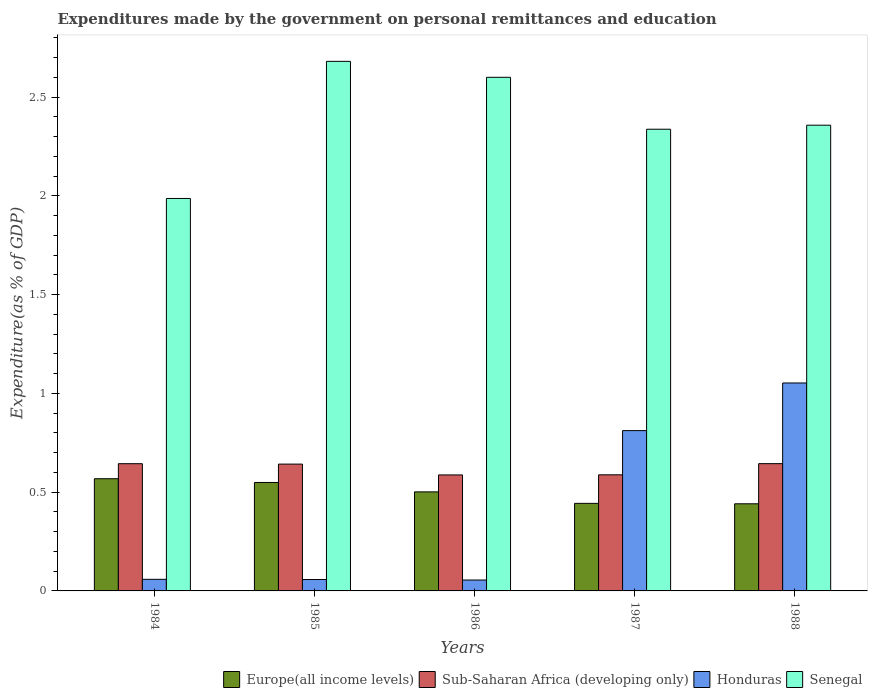How many different coloured bars are there?
Your answer should be very brief. 4. How many groups of bars are there?
Keep it short and to the point. 5. Are the number of bars on each tick of the X-axis equal?
Offer a very short reply. Yes. How many bars are there on the 4th tick from the left?
Provide a succinct answer. 4. What is the label of the 3rd group of bars from the left?
Offer a terse response. 1986. What is the expenditures made by the government on personal remittances and education in Europe(all income levels) in 1988?
Make the answer very short. 0.44. Across all years, what is the maximum expenditures made by the government on personal remittances and education in Europe(all income levels)?
Your answer should be compact. 0.57. Across all years, what is the minimum expenditures made by the government on personal remittances and education in Senegal?
Make the answer very short. 1.99. In which year was the expenditures made by the government on personal remittances and education in Senegal minimum?
Your response must be concise. 1984. What is the total expenditures made by the government on personal remittances and education in Honduras in the graph?
Provide a short and direct response. 2.04. What is the difference between the expenditures made by the government on personal remittances and education in Honduras in 1987 and that in 1988?
Provide a succinct answer. -0.24. What is the difference between the expenditures made by the government on personal remittances and education in Europe(all income levels) in 1986 and the expenditures made by the government on personal remittances and education in Honduras in 1985?
Give a very brief answer. 0.44. What is the average expenditures made by the government on personal remittances and education in Honduras per year?
Provide a short and direct response. 0.41. In the year 1985, what is the difference between the expenditures made by the government on personal remittances and education in Europe(all income levels) and expenditures made by the government on personal remittances and education in Sub-Saharan Africa (developing only)?
Provide a succinct answer. -0.09. What is the ratio of the expenditures made by the government on personal remittances and education in Senegal in 1984 to that in 1987?
Your answer should be very brief. 0.85. Is the expenditures made by the government on personal remittances and education in Honduras in 1985 less than that in 1987?
Your response must be concise. Yes. Is the difference between the expenditures made by the government on personal remittances and education in Europe(all income levels) in 1984 and 1985 greater than the difference between the expenditures made by the government on personal remittances and education in Sub-Saharan Africa (developing only) in 1984 and 1985?
Offer a very short reply. Yes. What is the difference between the highest and the second highest expenditures made by the government on personal remittances and education in Sub-Saharan Africa (developing only)?
Provide a succinct answer. 0. What is the difference between the highest and the lowest expenditures made by the government on personal remittances and education in Sub-Saharan Africa (developing only)?
Provide a short and direct response. 0.06. In how many years, is the expenditures made by the government on personal remittances and education in Europe(all income levels) greater than the average expenditures made by the government on personal remittances and education in Europe(all income levels) taken over all years?
Provide a succinct answer. 3. Is the sum of the expenditures made by the government on personal remittances and education in Sub-Saharan Africa (developing only) in 1986 and 1987 greater than the maximum expenditures made by the government on personal remittances and education in Europe(all income levels) across all years?
Keep it short and to the point. Yes. Is it the case that in every year, the sum of the expenditures made by the government on personal remittances and education in Senegal and expenditures made by the government on personal remittances and education in Honduras is greater than the sum of expenditures made by the government on personal remittances and education in Sub-Saharan Africa (developing only) and expenditures made by the government on personal remittances and education in Europe(all income levels)?
Make the answer very short. Yes. What does the 4th bar from the left in 1987 represents?
Offer a terse response. Senegal. What does the 2nd bar from the right in 1984 represents?
Provide a short and direct response. Honduras. Is it the case that in every year, the sum of the expenditures made by the government on personal remittances and education in Europe(all income levels) and expenditures made by the government on personal remittances and education in Senegal is greater than the expenditures made by the government on personal remittances and education in Honduras?
Provide a short and direct response. Yes. Are all the bars in the graph horizontal?
Make the answer very short. No. Does the graph contain any zero values?
Your response must be concise. No. How are the legend labels stacked?
Give a very brief answer. Horizontal. What is the title of the graph?
Make the answer very short. Expenditures made by the government on personal remittances and education. What is the label or title of the X-axis?
Keep it short and to the point. Years. What is the label or title of the Y-axis?
Provide a short and direct response. Expenditure(as % of GDP). What is the Expenditure(as % of GDP) of Europe(all income levels) in 1984?
Give a very brief answer. 0.57. What is the Expenditure(as % of GDP) of Sub-Saharan Africa (developing only) in 1984?
Your answer should be compact. 0.64. What is the Expenditure(as % of GDP) in Honduras in 1984?
Make the answer very short. 0.06. What is the Expenditure(as % of GDP) of Senegal in 1984?
Keep it short and to the point. 1.99. What is the Expenditure(as % of GDP) of Europe(all income levels) in 1985?
Offer a terse response. 0.55. What is the Expenditure(as % of GDP) of Sub-Saharan Africa (developing only) in 1985?
Keep it short and to the point. 0.64. What is the Expenditure(as % of GDP) of Honduras in 1985?
Give a very brief answer. 0.06. What is the Expenditure(as % of GDP) of Senegal in 1985?
Your answer should be compact. 2.68. What is the Expenditure(as % of GDP) in Europe(all income levels) in 1986?
Offer a very short reply. 0.5. What is the Expenditure(as % of GDP) of Sub-Saharan Africa (developing only) in 1986?
Ensure brevity in your answer.  0.59. What is the Expenditure(as % of GDP) of Honduras in 1986?
Your response must be concise. 0.06. What is the Expenditure(as % of GDP) of Senegal in 1986?
Offer a terse response. 2.6. What is the Expenditure(as % of GDP) of Europe(all income levels) in 1987?
Provide a short and direct response. 0.44. What is the Expenditure(as % of GDP) in Sub-Saharan Africa (developing only) in 1987?
Ensure brevity in your answer.  0.59. What is the Expenditure(as % of GDP) of Honduras in 1987?
Your answer should be very brief. 0.81. What is the Expenditure(as % of GDP) in Senegal in 1987?
Provide a succinct answer. 2.34. What is the Expenditure(as % of GDP) in Europe(all income levels) in 1988?
Offer a very short reply. 0.44. What is the Expenditure(as % of GDP) of Sub-Saharan Africa (developing only) in 1988?
Provide a short and direct response. 0.64. What is the Expenditure(as % of GDP) of Honduras in 1988?
Give a very brief answer. 1.05. What is the Expenditure(as % of GDP) in Senegal in 1988?
Your response must be concise. 2.36. Across all years, what is the maximum Expenditure(as % of GDP) of Europe(all income levels)?
Your answer should be compact. 0.57. Across all years, what is the maximum Expenditure(as % of GDP) in Sub-Saharan Africa (developing only)?
Offer a terse response. 0.64. Across all years, what is the maximum Expenditure(as % of GDP) in Honduras?
Offer a terse response. 1.05. Across all years, what is the maximum Expenditure(as % of GDP) of Senegal?
Offer a very short reply. 2.68. Across all years, what is the minimum Expenditure(as % of GDP) of Europe(all income levels)?
Make the answer very short. 0.44. Across all years, what is the minimum Expenditure(as % of GDP) in Sub-Saharan Africa (developing only)?
Make the answer very short. 0.59. Across all years, what is the minimum Expenditure(as % of GDP) in Honduras?
Offer a terse response. 0.06. Across all years, what is the minimum Expenditure(as % of GDP) in Senegal?
Give a very brief answer. 1.99. What is the total Expenditure(as % of GDP) of Europe(all income levels) in the graph?
Keep it short and to the point. 2.5. What is the total Expenditure(as % of GDP) of Sub-Saharan Africa (developing only) in the graph?
Offer a very short reply. 3.11. What is the total Expenditure(as % of GDP) of Honduras in the graph?
Your answer should be compact. 2.04. What is the total Expenditure(as % of GDP) of Senegal in the graph?
Your response must be concise. 11.96. What is the difference between the Expenditure(as % of GDP) in Europe(all income levels) in 1984 and that in 1985?
Offer a very short reply. 0.02. What is the difference between the Expenditure(as % of GDP) in Sub-Saharan Africa (developing only) in 1984 and that in 1985?
Your answer should be very brief. 0. What is the difference between the Expenditure(as % of GDP) in Honduras in 1984 and that in 1985?
Offer a terse response. 0. What is the difference between the Expenditure(as % of GDP) of Senegal in 1984 and that in 1985?
Ensure brevity in your answer.  -0.69. What is the difference between the Expenditure(as % of GDP) of Europe(all income levels) in 1984 and that in 1986?
Keep it short and to the point. 0.07. What is the difference between the Expenditure(as % of GDP) in Sub-Saharan Africa (developing only) in 1984 and that in 1986?
Give a very brief answer. 0.06. What is the difference between the Expenditure(as % of GDP) of Honduras in 1984 and that in 1986?
Give a very brief answer. 0. What is the difference between the Expenditure(as % of GDP) of Senegal in 1984 and that in 1986?
Ensure brevity in your answer.  -0.61. What is the difference between the Expenditure(as % of GDP) of Europe(all income levels) in 1984 and that in 1987?
Give a very brief answer. 0.12. What is the difference between the Expenditure(as % of GDP) in Sub-Saharan Africa (developing only) in 1984 and that in 1987?
Provide a succinct answer. 0.06. What is the difference between the Expenditure(as % of GDP) in Honduras in 1984 and that in 1987?
Ensure brevity in your answer.  -0.75. What is the difference between the Expenditure(as % of GDP) in Senegal in 1984 and that in 1987?
Ensure brevity in your answer.  -0.35. What is the difference between the Expenditure(as % of GDP) of Europe(all income levels) in 1984 and that in 1988?
Keep it short and to the point. 0.13. What is the difference between the Expenditure(as % of GDP) in Sub-Saharan Africa (developing only) in 1984 and that in 1988?
Your response must be concise. -0. What is the difference between the Expenditure(as % of GDP) in Honduras in 1984 and that in 1988?
Keep it short and to the point. -0.99. What is the difference between the Expenditure(as % of GDP) in Senegal in 1984 and that in 1988?
Make the answer very short. -0.37. What is the difference between the Expenditure(as % of GDP) in Europe(all income levels) in 1985 and that in 1986?
Offer a very short reply. 0.05. What is the difference between the Expenditure(as % of GDP) in Sub-Saharan Africa (developing only) in 1985 and that in 1986?
Make the answer very short. 0.05. What is the difference between the Expenditure(as % of GDP) of Honduras in 1985 and that in 1986?
Provide a succinct answer. 0. What is the difference between the Expenditure(as % of GDP) in Senegal in 1985 and that in 1986?
Offer a very short reply. 0.08. What is the difference between the Expenditure(as % of GDP) in Europe(all income levels) in 1985 and that in 1987?
Provide a short and direct response. 0.11. What is the difference between the Expenditure(as % of GDP) of Sub-Saharan Africa (developing only) in 1985 and that in 1987?
Give a very brief answer. 0.05. What is the difference between the Expenditure(as % of GDP) in Honduras in 1985 and that in 1987?
Provide a succinct answer. -0.75. What is the difference between the Expenditure(as % of GDP) of Senegal in 1985 and that in 1987?
Your response must be concise. 0.34. What is the difference between the Expenditure(as % of GDP) of Europe(all income levels) in 1985 and that in 1988?
Your answer should be compact. 0.11. What is the difference between the Expenditure(as % of GDP) in Sub-Saharan Africa (developing only) in 1985 and that in 1988?
Keep it short and to the point. -0. What is the difference between the Expenditure(as % of GDP) of Honduras in 1985 and that in 1988?
Provide a short and direct response. -1. What is the difference between the Expenditure(as % of GDP) in Senegal in 1985 and that in 1988?
Your answer should be very brief. 0.32. What is the difference between the Expenditure(as % of GDP) of Europe(all income levels) in 1986 and that in 1987?
Your answer should be very brief. 0.06. What is the difference between the Expenditure(as % of GDP) in Sub-Saharan Africa (developing only) in 1986 and that in 1987?
Ensure brevity in your answer.  -0. What is the difference between the Expenditure(as % of GDP) of Honduras in 1986 and that in 1987?
Provide a succinct answer. -0.76. What is the difference between the Expenditure(as % of GDP) of Senegal in 1986 and that in 1987?
Ensure brevity in your answer.  0.26. What is the difference between the Expenditure(as % of GDP) in Europe(all income levels) in 1986 and that in 1988?
Your answer should be compact. 0.06. What is the difference between the Expenditure(as % of GDP) in Sub-Saharan Africa (developing only) in 1986 and that in 1988?
Give a very brief answer. -0.06. What is the difference between the Expenditure(as % of GDP) in Honduras in 1986 and that in 1988?
Offer a terse response. -1. What is the difference between the Expenditure(as % of GDP) in Senegal in 1986 and that in 1988?
Your answer should be very brief. 0.24. What is the difference between the Expenditure(as % of GDP) of Europe(all income levels) in 1987 and that in 1988?
Your response must be concise. 0. What is the difference between the Expenditure(as % of GDP) of Sub-Saharan Africa (developing only) in 1987 and that in 1988?
Keep it short and to the point. -0.06. What is the difference between the Expenditure(as % of GDP) of Honduras in 1987 and that in 1988?
Offer a very short reply. -0.24. What is the difference between the Expenditure(as % of GDP) of Senegal in 1987 and that in 1988?
Offer a terse response. -0.02. What is the difference between the Expenditure(as % of GDP) of Europe(all income levels) in 1984 and the Expenditure(as % of GDP) of Sub-Saharan Africa (developing only) in 1985?
Provide a succinct answer. -0.07. What is the difference between the Expenditure(as % of GDP) in Europe(all income levels) in 1984 and the Expenditure(as % of GDP) in Honduras in 1985?
Ensure brevity in your answer.  0.51. What is the difference between the Expenditure(as % of GDP) in Europe(all income levels) in 1984 and the Expenditure(as % of GDP) in Senegal in 1985?
Your response must be concise. -2.11. What is the difference between the Expenditure(as % of GDP) of Sub-Saharan Africa (developing only) in 1984 and the Expenditure(as % of GDP) of Honduras in 1985?
Make the answer very short. 0.59. What is the difference between the Expenditure(as % of GDP) of Sub-Saharan Africa (developing only) in 1984 and the Expenditure(as % of GDP) of Senegal in 1985?
Ensure brevity in your answer.  -2.04. What is the difference between the Expenditure(as % of GDP) of Honduras in 1984 and the Expenditure(as % of GDP) of Senegal in 1985?
Give a very brief answer. -2.62. What is the difference between the Expenditure(as % of GDP) of Europe(all income levels) in 1984 and the Expenditure(as % of GDP) of Sub-Saharan Africa (developing only) in 1986?
Make the answer very short. -0.02. What is the difference between the Expenditure(as % of GDP) of Europe(all income levels) in 1984 and the Expenditure(as % of GDP) of Honduras in 1986?
Ensure brevity in your answer.  0.51. What is the difference between the Expenditure(as % of GDP) of Europe(all income levels) in 1984 and the Expenditure(as % of GDP) of Senegal in 1986?
Your answer should be very brief. -2.03. What is the difference between the Expenditure(as % of GDP) in Sub-Saharan Africa (developing only) in 1984 and the Expenditure(as % of GDP) in Honduras in 1986?
Offer a very short reply. 0.59. What is the difference between the Expenditure(as % of GDP) of Sub-Saharan Africa (developing only) in 1984 and the Expenditure(as % of GDP) of Senegal in 1986?
Keep it short and to the point. -1.96. What is the difference between the Expenditure(as % of GDP) in Honduras in 1984 and the Expenditure(as % of GDP) in Senegal in 1986?
Provide a succinct answer. -2.54. What is the difference between the Expenditure(as % of GDP) in Europe(all income levels) in 1984 and the Expenditure(as % of GDP) in Sub-Saharan Africa (developing only) in 1987?
Keep it short and to the point. -0.02. What is the difference between the Expenditure(as % of GDP) of Europe(all income levels) in 1984 and the Expenditure(as % of GDP) of Honduras in 1987?
Provide a succinct answer. -0.24. What is the difference between the Expenditure(as % of GDP) of Europe(all income levels) in 1984 and the Expenditure(as % of GDP) of Senegal in 1987?
Keep it short and to the point. -1.77. What is the difference between the Expenditure(as % of GDP) of Sub-Saharan Africa (developing only) in 1984 and the Expenditure(as % of GDP) of Honduras in 1987?
Provide a succinct answer. -0.17. What is the difference between the Expenditure(as % of GDP) of Sub-Saharan Africa (developing only) in 1984 and the Expenditure(as % of GDP) of Senegal in 1987?
Keep it short and to the point. -1.69. What is the difference between the Expenditure(as % of GDP) of Honduras in 1984 and the Expenditure(as % of GDP) of Senegal in 1987?
Provide a succinct answer. -2.28. What is the difference between the Expenditure(as % of GDP) of Europe(all income levels) in 1984 and the Expenditure(as % of GDP) of Sub-Saharan Africa (developing only) in 1988?
Provide a succinct answer. -0.08. What is the difference between the Expenditure(as % of GDP) of Europe(all income levels) in 1984 and the Expenditure(as % of GDP) of Honduras in 1988?
Your answer should be very brief. -0.48. What is the difference between the Expenditure(as % of GDP) of Europe(all income levels) in 1984 and the Expenditure(as % of GDP) of Senegal in 1988?
Offer a terse response. -1.79. What is the difference between the Expenditure(as % of GDP) of Sub-Saharan Africa (developing only) in 1984 and the Expenditure(as % of GDP) of Honduras in 1988?
Keep it short and to the point. -0.41. What is the difference between the Expenditure(as % of GDP) of Sub-Saharan Africa (developing only) in 1984 and the Expenditure(as % of GDP) of Senegal in 1988?
Keep it short and to the point. -1.71. What is the difference between the Expenditure(as % of GDP) of Honduras in 1984 and the Expenditure(as % of GDP) of Senegal in 1988?
Offer a very short reply. -2.3. What is the difference between the Expenditure(as % of GDP) of Europe(all income levels) in 1985 and the Expenditure(as % of GDP) of Sub-Saharan Africa (developing only) in 1986?
Your response must be concise. -0.04. What is the difference between the Expenditure(as % of GDP) of Europe(all income levels) in 1985 and the Expenditure(as % of GDP) of Honduras in 1986?
Offer a terse response. 0.49. What is the difference between the Expenditure(as % of GDP) of Europe(all income levels) in 1985 and the Expenditure(as % of GDP) of Senegal in 1986?
Your answer should be very brief. -2.05. What is the difference between the Expenditure(as % of GDP) of Sub-Saharan Africa (developing only) in 1985 and the Expenditure(as % of GDP) of Honduras in 1986?
Keep it short and to the point. 0.59. What is the difference between the Expenditure(as % of GDP) in Sub-Saharan Africa (developing only) in 1985 and the Expenditure(as % of GDP) in Senegal in 1986?
Provide a short and direct response. -1.96. What is the difference between the Expenditure(as % of GDP) in Honduras in 1985 and the Expenditure(as % of GDP) in Senegal in 1986?
Your answer should be compact. -2.54. What is the difference between the Expenditure(as % of GDP) in Europe(all income levels) in 1985 and the Expenditure(as % of GDP) in Sub-Saharan Africa (developing only) in 1987?
Offer a very short reply. -0.04. What is the difference between the Expenditure(as % of GDP) of Europe(all income levels) in 1985 and the Expenditure(as % of GDP) of Honduras in 1987?
Offer a terse response. -0.26. What is the difference between the Expenditure(as % of GDP) in Europe(all income levels) in 1985 and the Expenditure(as % of GDP) in Senegal in 1987?
Offer a very short reply. -1.79. What is the difference between the Expenditure(as % of GDP) in Sub-Saharan Africa (developing only) in 1985 and the Expenditure(as % of GDP) in Honduras in 1987?
Make the answer very short. -0.17. What is the difference between the Expenditure(as % of GDP) in Sub-Saharan Africa (developing only) in 1985 and the Expenditure(as % of GDP) in Senegal in 1987?
Provide a succinct answer. -1.7. What is the difference between the Expenditure(as % of GDP) in Honduras in 1985 and the Expenditure(as % of GDP) in Senegal in 1987?
Offer a terse response. -2.28. What is the difference between the Expenditure(as % of GDP) of Europe(all income levels) in 1985 and the Expenditure(as % of GDP) of Sub-Saharan Africa (developing only) in 1988?
Make the answer very short. -0.1. What is the difference between the Expenditure(as % of GDP) in Europe(all income levels) in 1985 and the Expenditure(as % of GDP) in Honduras in 1988?
Keep it short and to the point. -0.5. What is the difference between the Expenditure(as % of GDP) of Europe(all income levels) in 1985 and the Expenditure(as % of GDP) of Senegal in 1988?
Give a very brief answer. -1.81. What is the difference between the Expenditure(as % of GDP) of Sub-Saharan Africa (developing only) in 1985 and the Expenditure(as % of GDP) of Honduras in 1988?
Provide a short and direct response. -0.41. What is the difference between the Expenditure(as % of GDP) in Sub-Saharan Africa (developing only) in 1985 and the Expenditure(as % of GDP) in Senegal in 1988?
Your answer should be very brief. -1.72. What is the difference between the Expenditure(as % of GDP) in Honduras in 1985 and the Expenditure(as % of GDP) in Senegal in 1988?
Make the answer very short. -2.3. What is the difference between the Expenditure(as % of GDP) in Europe(all income levels) in 1986 and the Expenditure(as % of GDP) in Sub-Saharan Africa (developing only) in 1987?
Provide a succinct answer. -0.09. What is the difference between the Expenditure(as % of GDP) in Europe(all income levels) in 1986 and the Expenditure(as % of GDP) in Honduras in 1987?
Provide a short and direct response. -0.31. What is the difference between the Expenditure(as % of GDP) in Europe(all income levels) in 1986 and the Expenditure(as % of GDP) in Senegal in 1987?
Provide a succinct answer. -1.84. What is the difference between the Expenditure(as % of GDP) of Sub-Saharan Africa (developing only) in 1986 and the Expenditure(as % of GDP) of Honduras in 1987?
Give a very brief answer. -0.22. What is the difference between the Expenditure(as % of GDP) in Sub-Saharan Africa (developing only) in 1986 and the Expenditure(as % of GDP) in Senegal in 1987?
Ensure brevity in your answer.  -1.75. What is the difference between the Expenditure(as % of GDP) in Honduras in 1986 and the Expenditure(as % of GDP) in Senegal in 1987?
Make the answer very short. -2.28. What is the difference between the Expenditure(as % of GDP) in Europe(all income levels) in 1986 and the Expenditure(as % of GDP) in Sub-Saharan Africa (developing only) in 1988?
Provide a short and direct response. -0.14. What is the difference between the Expenditure(as % of GDP) of Europe(all income levels) in 1986 and the Expenditure(as % of GDP) of Honduras in 1988?
Give a very brief answer. -0.55. What is the difference between the Expenditure(as % of GDP) of Europe(all income levels) in 1986 and the Expenditure(as % of GDP) of Senegal in 1988?
Your answer should be very brief. -1.86. What is the difference between the Expenditure(as % of GDP) of Sub-Saharan Africa (developing only) in 1986 and the Expenditure(as % of GDP) of Honduras in 1988?
Provide a succinct answer. -0.47. What is the difference between the Expenditure(as % of GDP) in Sub-Saharan Africa (developing only) in 1986 and the Expenditure(as % of GDP) in Senegal in 1988?
Your answer should be compact. -1.77. What is the difference between the Expenditure(as % of GDP) of Honduras in 1986 and the Expenditure(as % of GDP) of Senegal in 1988?
Your response must be concise. -2.3. What is the difference between the Expenditure(as % of GDP) of Europe(all income levels) in 1987 and the Expenditure(as % of GDP) of Sub-Saharan Africa (developing only) in 1988?
Keep it short and to the point. -0.2. What is the difference between the Expenditure(as % of GDP) of Europe(all income levels) in 1987 and the Expenditure(as % of GDP) of Honduras in 1988?
Offer a terse response. -0.61. What is the difference between the Expenditure(as % of GDP) in Europe(all income levels) in 1987 and the Expenditure(as % of GDP) in Senegal in 1988?
Provide a succinct answer. -1.91. What is the difference between the Expenditure(as % of GDP) of Sub-Saharan Africa (developing only) in 1987 and the Expenditure(as % of GDP) of Honduras in 1988?
Provide a short and direct response. -0.47. What is the difference between the Expenditure(as % of GDP) of Sub-Saharan Africa (developing only) in 1987 and the Expenditure(as % of GDP) of Senegal in 1988?
Offer a terse response. -1.77. What is the difference between the Expenditure(as % of GDP) in Honduras in 1987 and the Expenditure(as % of GDP) in Senegal in 1988?
Provide a short and direct response. -1.55. What is the average Expenditure(as % of GDP) of Europe(all income levels) per year?
Your answer should be compact. 0.5. What is the average Expenditure(as % of GDP) of Sub-Saharan Africa (developing only) per year?
Provide a succinct answer. 0.62. What is the average Expenditure(as % of GDP) in Honduras per year?
Make the answer very short. 0.41. What is the average Expenditure(as % of GDP) of Senegal per year?
Keep it short and to the point. 2.39. In the year 1984, what is the difference between the Expenditure(as % of GDP) of Europe(all income levels) and Expenditure(as % of GDP) of Sub-Saharan Africa (developing only)?
Provide a succinct answer. -0.08. In the year 1984, what is the difference between the Expenditure(as % of GDP) in Europe(all income levels) and Expenditure(as % of GDP) in Honduras?
Your response must be concise. 0.51. In the year 1984, what is the difference between the Expenditure(as % of GDP) of Europe(all income levels) and Expenditure(as % of GDP) of Senegal?
Provide a short and direct response. -1.42. In the year 1984, what is the difference between the Expenditure(as % of GDP) of Sub-Saharan Africa (developing only) and Expenditure(as % of GDP) of Honduras?
Offer a very short reply. 0.59. In the year 1984, what is the difference between the Expenditure(as % of GDP) in Sub-Saharan Africa (developing only) and Expenditure(as % of GDP) in Senegal?
Offer a very short reply. -1.34. In the year 1984, what is the difference between the Expenditure(as % of GDP) of Honduras and Expenditure(as % of GDP) of Senegal?
Keep it short and to the point. -1.93. In the year 1985, what is the difference between the Expenditure(as % of GDP) of Europe(all income levels) and Expenditure(as % of GDP) of Sub-Saharan Africa (developing only)?
Provide a succinct answer. -0.09. In the year 1985, what is the difference between the Expenditure(as % of GDP) of Europe(all income levels) and Expenditure(as % of GDP) of Honduras?
Offer a terse response. 0.49. In the year 1985, what is the difference between the Expenditure(as % of GDP) in Europe(all income levels) and Expenditure(as % of GDP) in Senegal?
Provide a short and direct response. -2.13. In the year 1985, what is the difference between the Expenditure(as % of GDP) in Sub-Saharan Africa (developing only) and Expenditure(as % of GDP) in Honduras?
Provide a succinct answer. 0.58. In the year 1985, what is the difference between the Expenditure(as % of GDP) of Sub-Saharan Africa (developing only) and Expenditure(as % of GDP) of Senegal?
Offer a very short reply. -2.04. In the year 1985, what is the difference between the Expenditure(as % of GDP) in Honduras and Expenditure(as % of GDP) in Senegal?
Offer a very short reply. -2.62. In the year 1986, what is the difference between the Expenditure(as % of GDP) of Europe(all income levels) and Expenditure(as % of GDP) of Sub-Saharan Africa (developing only)?
Provide a short and direct response. -0.09. In the year 1986, what is the difference between the Expenditure(as % of GDP) in Europe(all income levels) and Expenditure(as % of GDP) in Honduras?
Offer a very short reply. 0.45. In the year 1986, what is the difference between the Expenditure(as % of GDP) in Europe(all income levels) and Expenditure(as % of GDP) in Senegal?
Provide a succinct answer. -2.1. In the year 1986, what is the difference between the Expenditure(as % of GDP) of Sub-Saharan Africa (developing only) and Expenditure(as % of GDP) of Honduras?
Provide a succinct answer. 0.53. In the year 1986, what is the difference between the Expenditure(as % of GDP) in Sub-Saharan Africa (developing only) and Expenditure(as % of GDP) in Senegal?
Make the answer very short. -2.01. In the year 1986, what is the difference between the Expenditure(as % of GDP) of Honduras and Expenditure(as % of GDP) of Senegal?
Offer a very short reply. -2.55. In the year 1987, what is the difference between the Expenditure(as % of GDP) of Europe(all income levels) and Expenditure(as % of GDP) of Sub-Saharan Africa (developing only)?
Provide a succinct answer. -0.14. In the year 1987, what is the difference between the Expenditure(as % of GDP) of Europe(all income levels) and Expenditure(as % of GDP) of Honduras?
Your response must be concise. -0.37. In the year 1987, what is the difference between the Expenditure(as % of GDP) of Europe(all income levels) and Expenditure(as % of GDP) of Senegal?
Your answer should be compact. -1.89. In the year 1987, what is the difference between the Expenditure(as % of GDP) in Sub-Saharan Africa (developing only) and Expenditure(as % of GDP) in Honduras?
Offer a terse response. -0.22. In the year 1987, what is the difference between the Expenditure(as % of GDP) of Sub-Saharan Africa (developing only) and Expenditure(as % of GDP) of Senegal?
Ensure brevity in your answer.  -1.75. In the year 1987, what is the difference between the Expenditure(as % of GDP) in Honduras and Expenditure(as % of GDP) in Senegal?
Offer a very short reply. -1.53. In the year 1988, what is the difference between the Expenditure(as % of GDP) in Europe(all income levels) and Expenditure(as % of GDP) in Sub-Saharan Africa (developing only)?
Offer a terse response. -0.2. In the year 1988, what is the difference between the Expenditure(as % of GDP) of Europe(all income levels) and Expenditure(as % of GDP) of Honduras?
Keep it short and to the point. -0.61. In the year 1988, what is the difference between the Expenditure(as % of GDP) of Europe(all income levels) and Expenditure(as % of GDP) of Senegal?
Your response must be concise. -1.92. In the year 1988, what is the difference between the Expenditure(as % of GDP) of Sub-Saharan Africa (developing only) and Expenditure(as % of GDP) of Honduras?
Provide a short and direct response. -0.41. In the year 1988, what is the difference between the Expenditure(as % of GDP) in Sub-Saharan Africa (developing only) and Expenditure(as % of GDP) in Senegal?
Keep it short and to the point. -1.71. In the year 1988, what is the difference between the Expenditure(as % of GDP) in Honduras and Expenditure(as % of GDP) in Senegal?
Offer a very short reply. -1.31. What is the ratio of the Expenditure(as % of GDP) of Europe(all income levels) in 1984 to that in 1985?
Ensure brevity in your answer.  1.03. What is the ratio of the Expenditure(as % of GDP) in Honduras in 1984 to that in 1985?
Your answer should be very brief. 1.02. What is the ratio of the Expenditure(as % of GDP) in Senegal in 1984 to that in 1985?
Ensure brevity in your answer.  0.74. What is the ratio of the Expenditure(as % of GDP) of Europe(all income levels) in 1984 to that in 1986?
Provide a short and direct response. 1.13. What is the ratio of the Expenditure(as % of GDP) of Sub-Saharan Africa (developing only) in 1984 to that in 1986?
Your response must be concise. 1.1. What is the ratio of the Expenditure(as % of GDP) of Honduras in 1984 to that in 1986?
Ensure brevity in your answer.  1.07. What is the ratio of the Expenditure(as % of GDP) of Senegal in 1984 to that in 1986?
Your response must be concise. 0.76. What is the ratio of the Expenditure(as % of GDP) in Europe(all income levels) in 1984 to that in 1987?
Give a very brief answer. 1.28. What is the ratio of the Expenditure(as % of GDP) of Sub-Saharan Africa (developing only) in 1984 to that in 1987?
Ensure brevity in your answer.  1.1. What is the ratio of the Expenditure(as % of GDP) of Honduras in 1984 to that in 1987?
Your answer should be very brief. 0.07. What is the ratio of the Expenditure(as % of GDP) in Senegal in 1984 to that in 1987?
Your response must be concise. 0.85. What is the ratio of the Expenditure(as % of GDP) of Europe(all income levels) in 1984 to that in 1988?
Make the answer very short. 1.29. What is the ratio of the Expenditure(as % of GDP) of Honduras in 1984 to that in 1988?
Your answer should be very brief. 0.06. What is the ratio of the Expenditure(as % of GDP) of Senegal in 1984 to that in 1988?
Offer a terse response. 0.84. What is the ratio of the Expenditure(as % of GDP) of Europe(all income levels) in 1985 to that in 1986?
Make the answer very short. 1.09. What is the ratio of the Expenditure(as % of GDP) of Sub-Saharan Africa (developing only) in 1985 to that in 1986?
Give a very brief answer. 1.09. What is the ratio of the Expenditure(as % of GDP) in Honduras in 1985 to that in 1986?
Offer a very short reply. 1.05. What is the ratio of the Expenditure(as % of GDP) of Senegal in 1985 to that in 1986?
Your answer should be compact. 1.03. What is the ratio of the Expenditure(as % of GDP) in Europe(all income levels) in 1985 to that in 1987?
Offer a terse response. 1.24. What is the ratio of the Expenditure(as % of GDP) of Sub-Saharan Africa (developing only) in 1985 to that in 1987?
Ensure brevity in your answer.  1.09. What is the ratio of the Expenditure(as % of GDP) of Honduras in 1985 to that in 1987?
Your answer should be very brief. 0.07. What is the ratio of the Expenditure(as % of GDP) in Senegal in 1985 to that in 1987?
Your answer should be compact. 1.15. What is the ratio of the Expenditure(as % of GDP) in Europe(all income levels) in 1985 to that in 1988?
Provide a succinct answer. 1.24. What is the ratio of the Expenditure(as % of GDP) of Sub-Saharan Africa (developing only) in 1985 to that in 1988?
Keep it short and to the point. 1. What is the ratio of the Expenditure(as % of GDP) of Honduras in 1985 to that in 1988?
Offer a very short reply. 0.05. What is the ratio of the Expenditure(as % of GDP) of Senegal in 1985 to that in 1988?
Give a very brief answer. 1.14. What is the ratio of the Expenditure(as % of GDP) in Europe(all income levels) in 1986 to that in 1987?
Provide a succinct answer. 1.13. What is the ratio of the Expenditure(as % of GDP) in Sub-Saharan Africa (developing only) in 1986 to that in 1987?
Provide a short and direct response. 1. What is the ratio of the Expenditure(as % of GDP) in Honduras in 1986 to that in 1987?
Your response must be concise. 0.07. What is the ratio of the Expenditure(as % of GDP) in Senegal in 1986 to that in 1987?
Provide a short and direct response. 1.11. What is the ratio of the Expenditure(as % of GDP) in Europe(all income levels) in 1986 to that in 1988?
Your answer should be very brief. 1.14. What is the ratio of the Expenditure(as % of GDP) in Sub-Saharan Africa (developing only) in 1986 to that in 1988?
Offer a very short reply. 0.91. What is the ratio of the Expenditure(as % of GDP) in Honduras in 1986 to that in 1988?
Your response must be concise. 0.05. What is the ratio of the Expenditure(as % of GDP) of Senegal in 1986 to that in 1988?
Your response must be concise. 1.1. What is the ratio of the Expenditure(as % of GDP) in Europe(all income levels) in 1987 to that in 1988?
Offer a very short reply. 1. What is the ratio of the Expenditure(as % of GDP) in Sub-Saharan Africa (developing only) in 1987 to that in 1988?
Offer a terse response. 0.91. What is the ratio of the Expenditure(as % of GDP) of Honduras in 1987 to that in 1988?
Offer a terse response. 0.77. What is the ratio of the Expenditure(as % of GDP) in Senegal in 1987 to that in 1988?
Offer a very short reply. 0.99. What is the difference between the highest and the second highest Expenditure(as % of GDP) in Europe(all income levels)?
Offer a terse response. 0.02. What is the difference between the highest and the second highest Expenditure(as % of GDP) in Sub-Saharan Africa (developing only)?
Your response must be concise. 0. What is the difference between the highest and the second highest Expenditure(as % of GDP) in Honduras?
Your response must be concise. 0.24. What is the difference between the highest and the second highest Expenditure(as % of GDP) of Senegal?
Offer a terse response. 0.08. What is the difference between the highest and the lowest Expenditure(as % of GDP) of Europe(all income levels)?
Keep it short and to the point. 0.13. What is the difference between the highest and the lowest Expenditure(as % of GDP) in Sub-Saharan Africa (developing only)?
Ensure brevity in your answer.  0.06. What is the difference between the highest and the lowest Expenditure(as % of GDP) of Senegal?
Your answer should be compact. 0.69. 